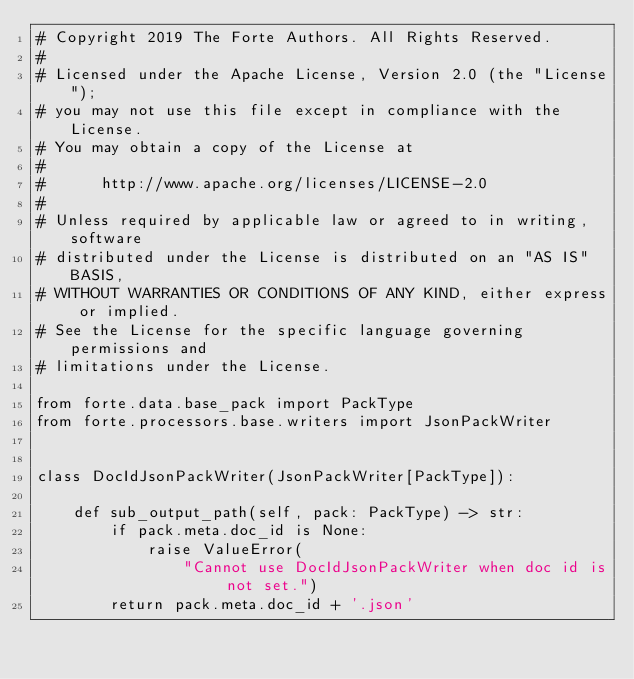Convert code to text. <code><loc_0><loc_0><loc_500><loc_500><_Python_># Copyright 2019 The Forte Authors. All Rights Reserved.
#
# Licensed under the Apache License, Version 2.0 (the "License");
# you may not use this file except in compliance with the License.
# You may obtain a copy of the License at
#
#      http://www.apache.org/licenses/LICENSE-2.0
#
# Unless required by applicable law or agreed to in writing, software
# distributed under the License is distributed on an "AS IS" BASIS,
# WITHOUT WARRANTIES OR CONDITIONS OF ANY KIND, either express or implied.
# See the License for the specific language governing permissions and
# limitations under the License.

from forte.data.base_pack import PackType
from forte.processors.base.writers import JsonPackWriter


class DocIdJsonPackWriter(JsonPackWriter[PackType]):

    def sub_output_path(self, pack: PackType) -> str:
        if pack.meta.doc_id is None:
            raise ValueError(
                "Cannot use DocIdJsonPackWriter when doc id is not set.")
        return pack.meta.doc_id + '.json'
</code> 